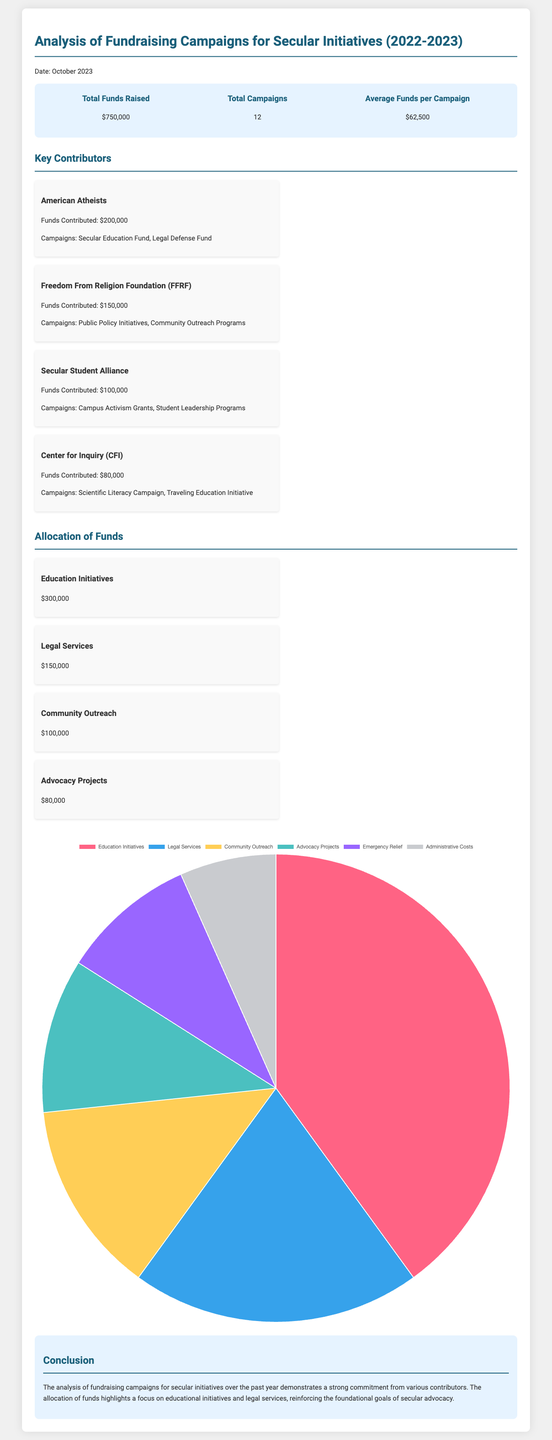What is the total funds raised? The total funds raised is clearly stated in the summary section of the document as $750,000.
Answer: $750,000 Who is the contributor of the highest funding? The document lists key contributors, with American Atheists contributing the highest amount of $200,000.
Answer: American Atheists How many campaigns were there in total? The total number of campaigns is mentioned in the summary as 12.
Answer: 12 What amount was allocated to education initiatives? The allocation of funds specifies that $300,000 was designated for education initiatives.
Answer: $300,000 What was the average funds raised per campaign? The summary indicates the average funds raised per campaign, calculated to be $62,500.
Answer: $62,500 Which organization contributed to community outreach programs? The contributor listed for community outreach programs is Freedom From Religion Foundation (FFRF) with $150,000.
Answer: Freedom From Religion Foundation (FFRF) What percentage of the total funds raised was allocated to legal services? The funds allocated to legal services are stated as $150,000, which is 20% of the total raised $750,000.
Answer: 20% What is the focus of the concluded analysis? The conclusion reflects a commitment to educational initiatives and legal services, emphasizing the goals of secular advocacy.
Answer: Educational initiatives and legal services 